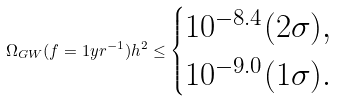Convert formula to latex. <formula><loc_0><loc_0><loc_500><loc_500>\Omega _ { G W } ( f = 1 y r ^ { - 1 } ) h ^ { 2 } \leq \begin{cases} 1 0 ^ { - 8 . 4 } ( 2 \sigma ) , \\ 1 0 ^ { - 9 . 0 } ( 1 \sigma ) . \end{cases}</formula> 